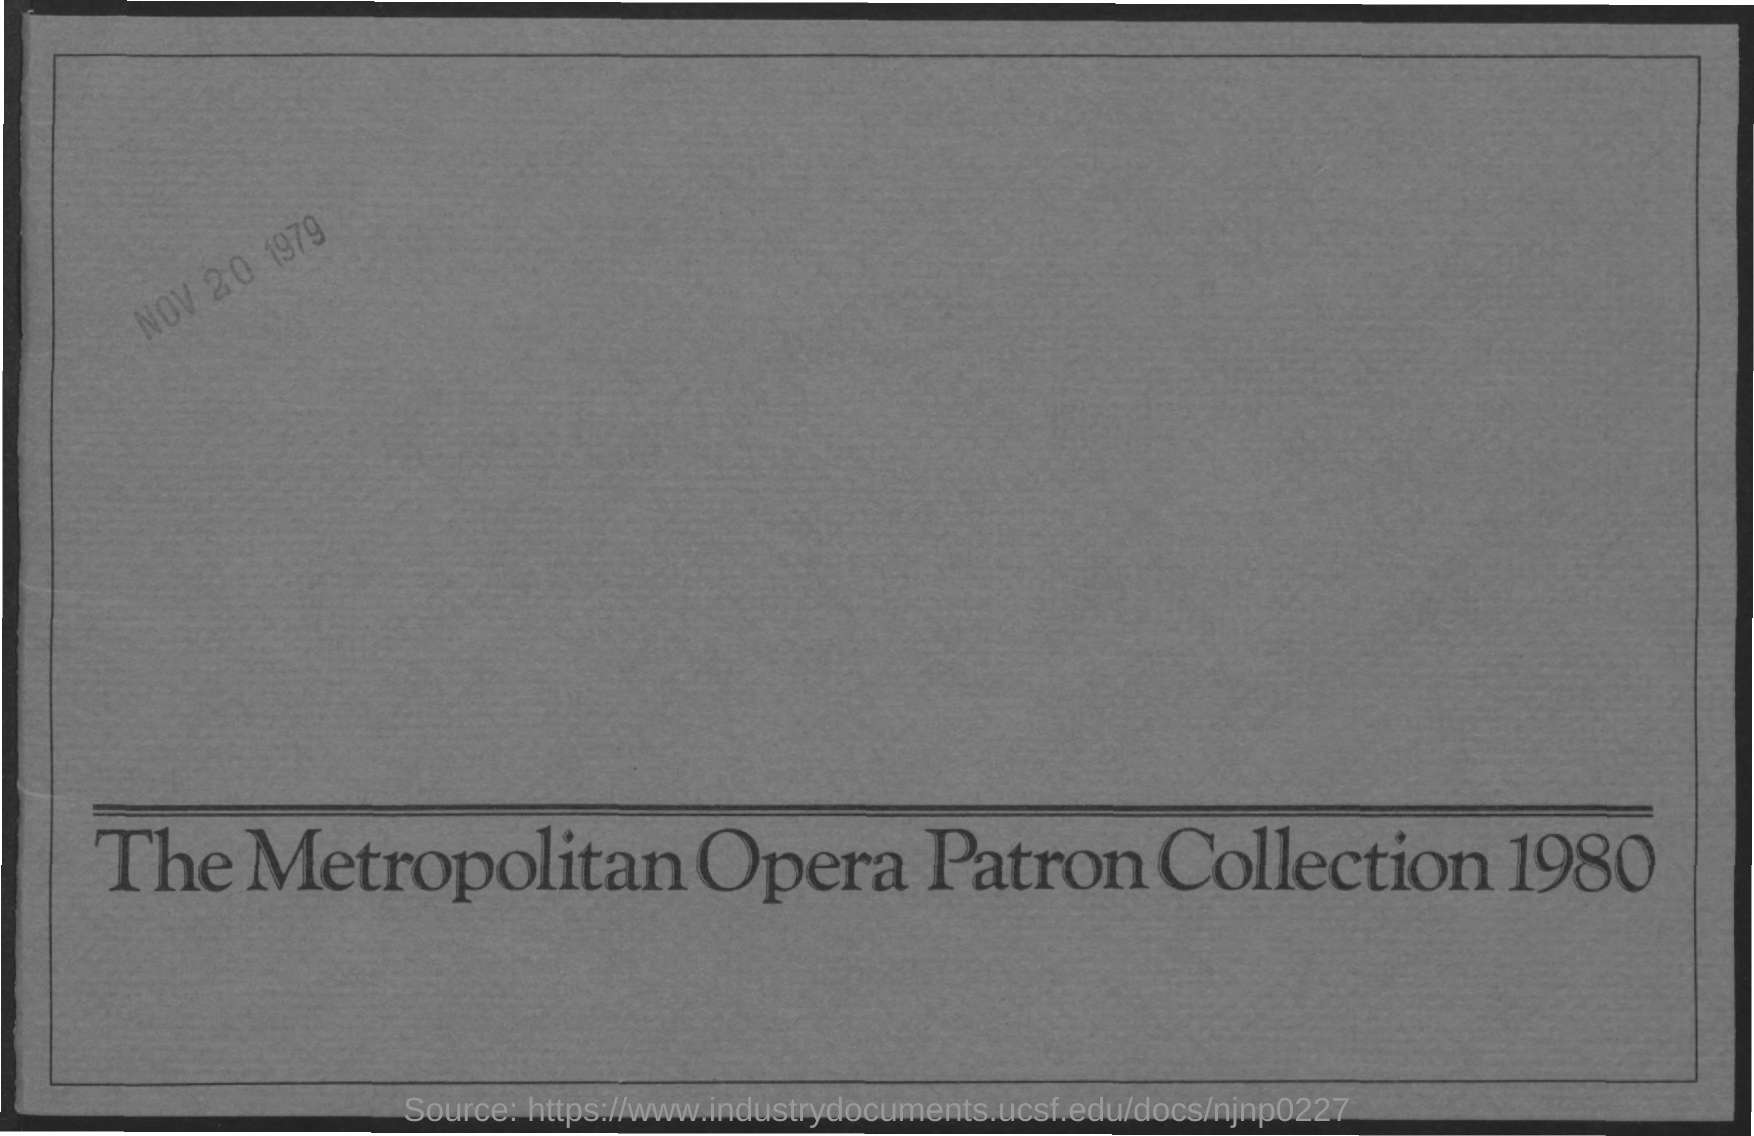What is the document title?
Offer a terse response. The Metropolitan Opera Patron Collection 1980. When is the document dated?
Ensure brevity in your answer.  NOV 20 1979. 